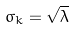Convert formula to latex. <formula><loc_0><loc_0><loc_500><loc_500>\sigma _ { k } = \sqrt { \lambda }</formula> 